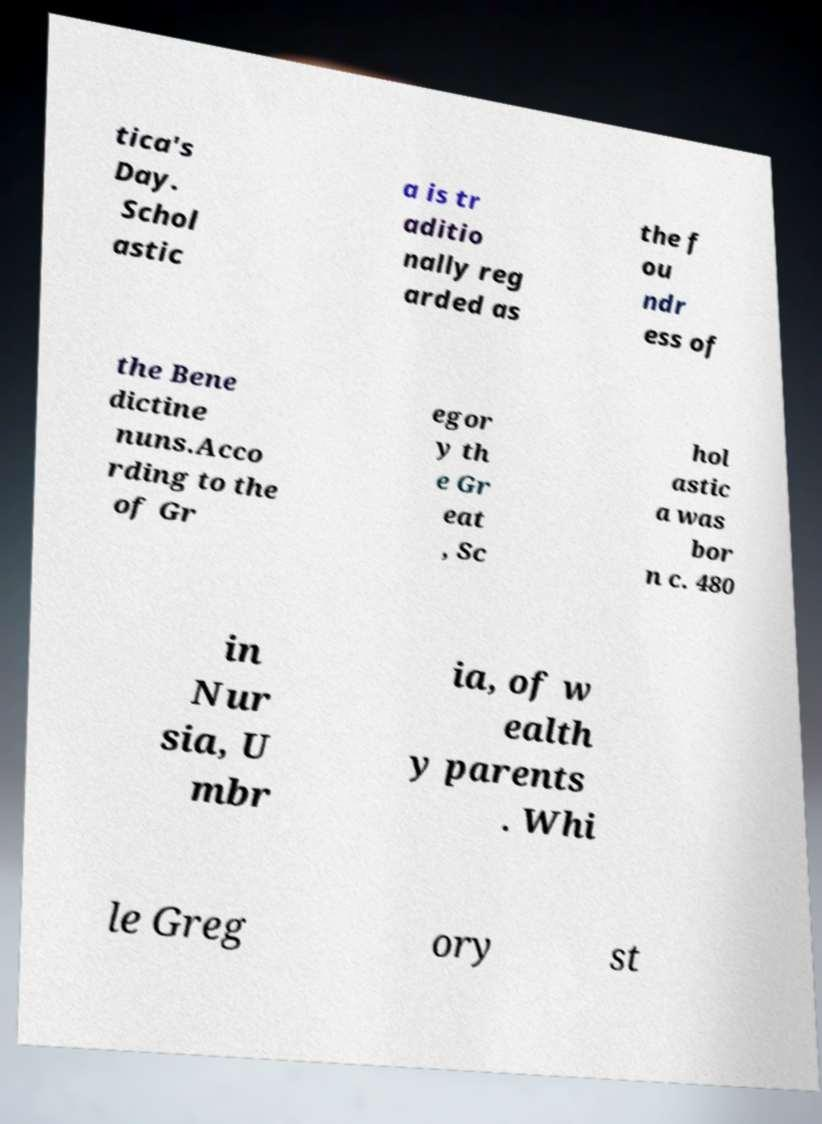For documentation purposes, I need the text within this image transcribed. Could you provide that? tica's Day. Schol astic a is tr aditio nally reg arded as the f ou ndr ess of the Bene dictine nuns.Acco rding to the of Gr egor y th e Gr eat , Sc hol astic a was bor n c. 480 in Nur sia, U mbr ia, of w ealth y parents . Whi le Greg ory st 